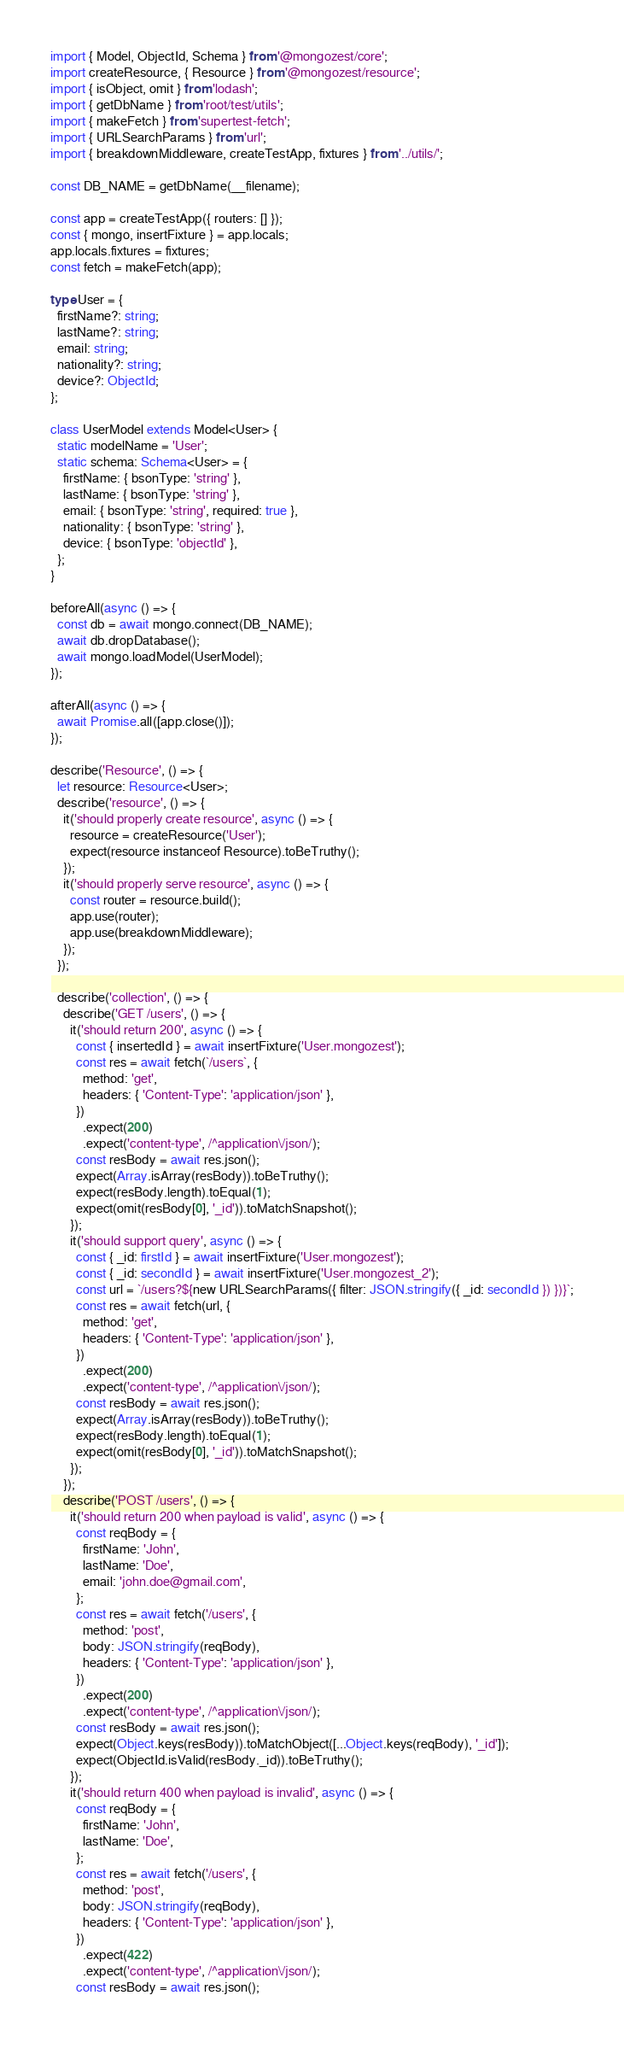Convert code to text. <code><loc_0><loc_0><loc_500><loc_500><_TypeScript_>import { Model, ObjectId, Schema } from '@mongozest/core';
import createResource, { Resource } from '@mongozest/resource';
import { isObject, omit } from 'lodash';
import { getDbName } from 'root/test/utils';
import { makeFetch } from 'supertest-fetch';
import { URLSearchParams } from 'url';
import { breakdownMiddleware, createTestApp, fixtures } from '../utils/';

const DB_NAME = getDbName(__filename);

const app = createTestApp({ routers: [] });
const { mongo, insertFixture } = app.locals;
app.locals.fixtures = fixtures;
const fetch = makeFetch(app);

type User = {
  firstName?: string;
  lastName?: string;
  email: string;
  nationality?: string;
  device?: ObjectId;
};

class UserModel extends Model<User> {
  static modelName = 'User';
  static schema: Schema<User> = {
    firstName: { bsonType: 'string' },
    lastName: { bsonType: 'string' },
    email: { bsonType: 'string', required: true },
    nationality: { bsonType: 'string' },
    device: { bsonType: 'objectId' },
  };
}

beforeAll(async () => {
  const db = await mongo.connect(DB_NAME);
  await db.dropDatabase();
  await mongo.loadModel(UserModel);
});

afterAll(async () => {
  await Promise.all([app.close()]);
});

describe('Resource', () => {
  let resource: Resource<User>;
  describe('resource', () => {
    it('should properly create resource', async () => {
      resource = createResource('User');
      expect(resource instanceof Resource).toBeTruthy();
    });
    it('should properly serve resource', async () => {
      const router = resource.build();
      app.use(router);
      app.use(breakdownMiddleware);
    });
  });

  describe('collection', () => {
    describe('GET /users', () => {
      it('should return 200', async () => {
        const { insertedId } = await insertFixture('User.mongozest');
        const res = await fetch(`/users`, {
          method: 'get',
          headers: { 'Content-Type': 'application/json' },
        })
          .expect(200)
          .expect('content-type', /^application\/json/);
        const resBody = await res.json();
        expect(Array.isArray(resBody)).toBeTruthy();
        expect(resBody.length).toEqual(1);
        expect(omit(resBody[0], '_id')).toMatchSnapshot();
      });
      it('should support query', async () => {
        const { _id: firstId } = await insertFixture('User.mongozest');
        const { _id: secondId } = await insertFixture('User.mongozest_2');
        const url = `/users?${new URLSearchParams({ filter: JSON.stringify({ _id: secondId }) })}`;
        const res = await fetch(url, {
          method: 'get',
          headers: { 'Content-Type': 'application/json' },
        })
          .expect(200)
          .expect('content-type', /^application\/json/);
        const resBody = await res.json();
        expect(Array.isArray(resBody)).toBeTruthy();
        expect(resBody.length).toEqual(1);
        expect(omit(resBody[0], '_id')).toMatchSnapshot();
      });
    });
    describe('POST /users', () => {
      it('should return 200 when payload is valid', async () => {
        const reqBody = {
          firstName: 'John',
          lastName: 'Doe',
          email: 'john.doe@gmail.com',
        };
        const res = await fetch('/users', {
          method: 'post',
          body: JSON.stringify(reqBody),
          headers: { 'Content-Type': 'application/json' },
        })
          .expect(200)
          .expect('content-type', /^application\/json/);
        const resBody = await res.json();
        expect(Object.keys(resBody)).toMatchObject([...Object.keys(reqBody), '_id']);
        expect(ObjectId.isValid(resBody._id)).toBeTruthy();
      });
      it('should return 400 when payload is invalid', async () => {
        const reqBody = {
          firstName: 'John',
          lastName: 'Doe',
        };
        const res = await fetch('/users', {
          method: 'post',
          body: JSON.stringify(reqBody),
          headers: { 'Content-Type': 'application/json' },
        })
          .expect(422)
          .expect('content-type', /^application\/json/);
        const resBody = await res.json();</code> 